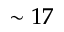Convert formula to latex. <formula><loc_0><loc_0><loc_500><loc_500>\sim 1 7</formula> 